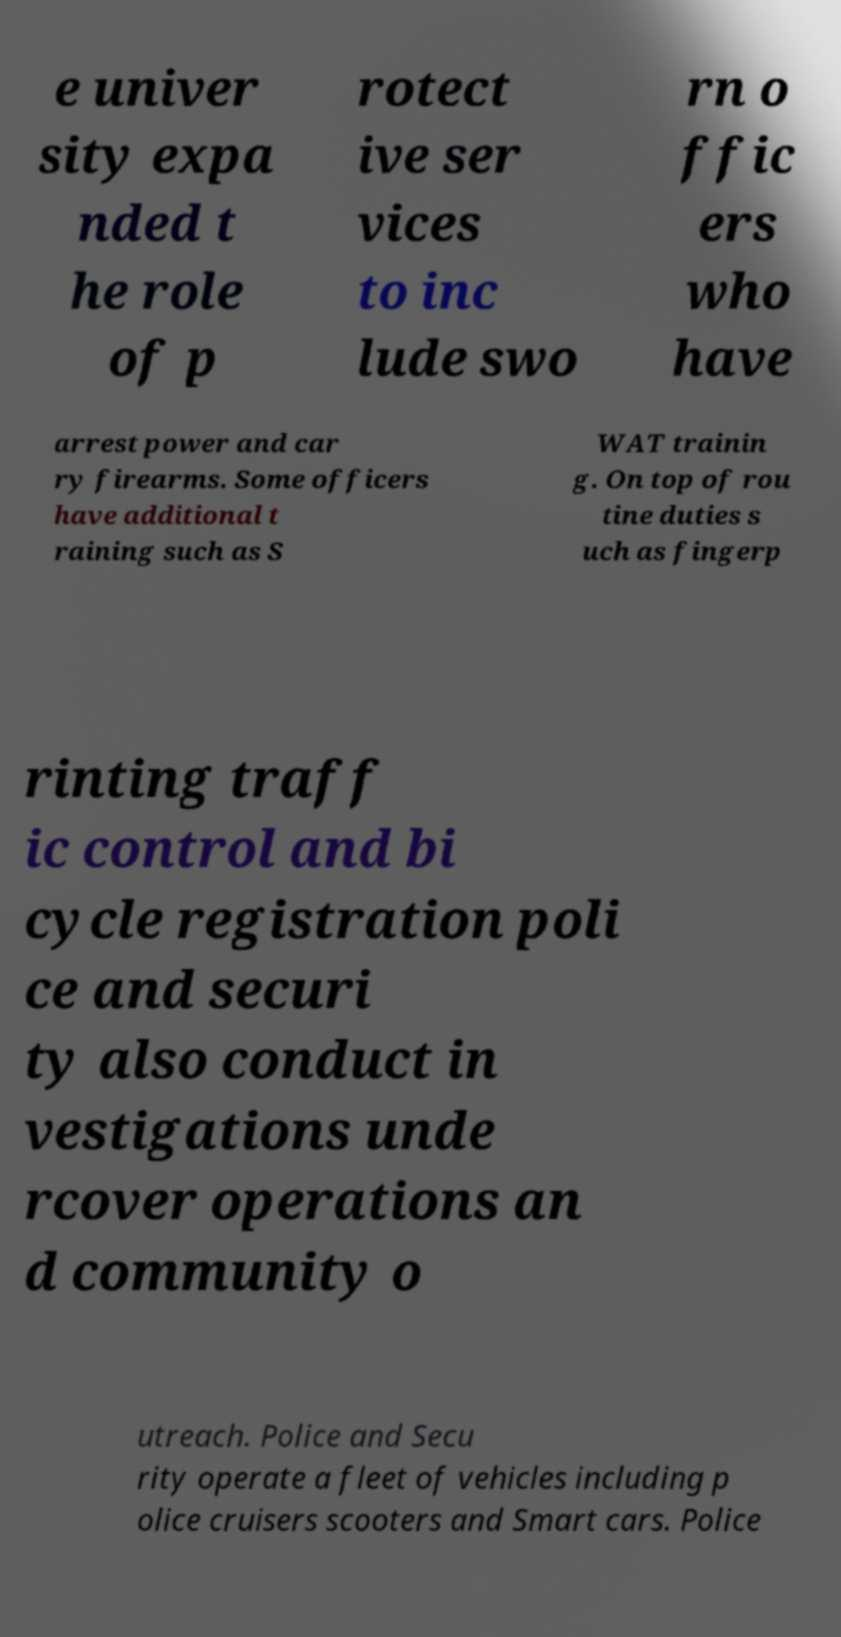Could you assist in decoding the text presented in this image and type it out clearly? e univer sity expa nded t he role of p rotect ive ser vices to inc lude swo rn o ffic ers who have arrest power and car ry firearms. Some officers have additional t raining such as S WAT trainin g. On top of rou tine duties s uch as fingerp rinting traff ic control and bi cycle registration poli ce and securi ty also conduct in vestigations unde rcover operations an d community o utreach. Police and Secu rity operate a fleet of vehicles including p olice cruisers scooters and Smart cars. Police 